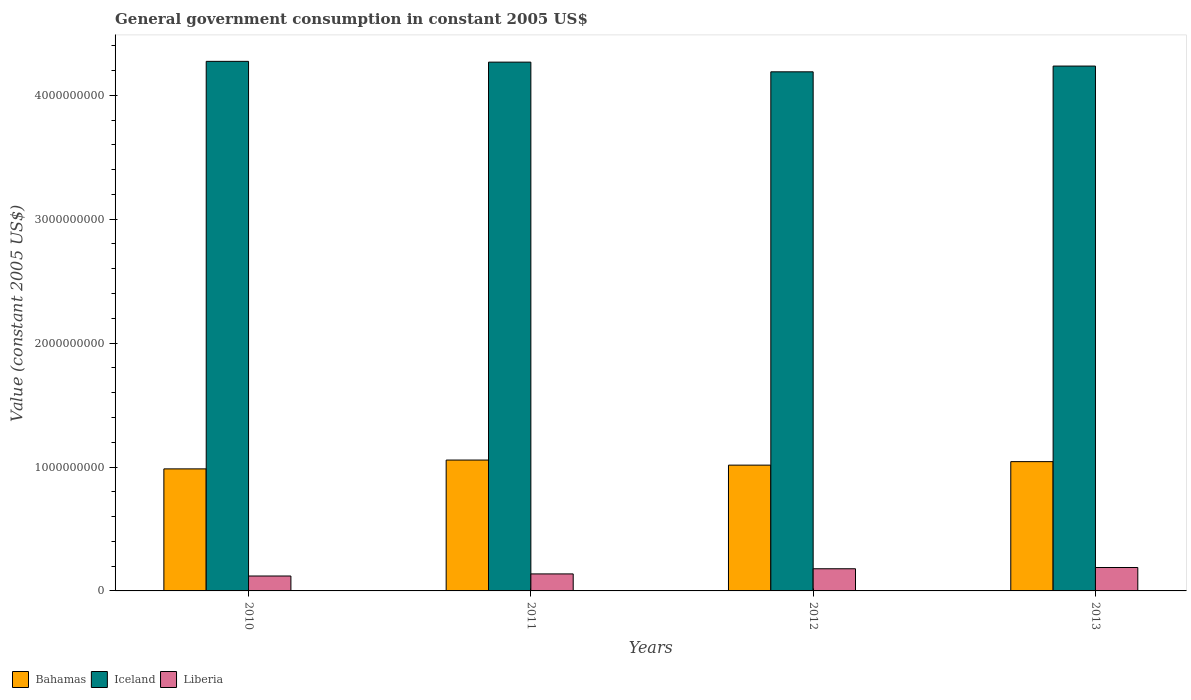Are the number of bars per tick equal to the number of legend labels?
Keep it short and to the point. Yes. How many bars are there on the 4th tick from the right?
Offer a very short reply. 3. In how many cases, is the number of bars for a given year not equal to the number of legend labels?
Your response must be concise. 0. What is the government conusmption in Bahamas in 2012?
Provide a succinct answer. 1.02e+09. Across all years, what is the maximum government conusmption in Iceland?
Your answer should be compact. 4.27e+09. Across all years, what is the minimum government conusmption in Liberia?
Offer a terse response. 1.20e+08. In which year was the government conusmption in Bahamas maximum?
Give a very brief answer. 2011. What is the total government conusmption in Bahamas in the graph?
Keep it short and to the point. 4.10e+09. What is the difference between the government conusmption in Liberia in 2011 and that in 2012?
Offer a very short reply. -4.16e+07. What is the difference between the government conusmption in Iceland in 2010 and the government conusmption in Liberia in 2012?
Provide a short and direct response. 4.10e+09. What is the average government conusmption in Liberia per year?
Give a very brief answer. 1.56e+08. In the year 2013, what is the difference between the government conusmption in Bahamas and government conusmption in Liberia?
Offer a terse response. 8.55e+08. In how many years, is the government conusmption in Liberia greater than 2800000000 US$?
Ensure brevity in your answer.  0. What is the ratio of the government conusmption in Bahamas in 2012 to that in 2013?
Ensure brevity in your answer.  0.97. Is the government conusmption in Liberia in 2011 less than that in 2012?
Ensure brevity in your answer.  Yes. What is the difference between the highest and the second highest government conusmption in Bahamas?
Your answer should be very brief. 1.28e+07. What is the difference between the highest and the lowest government conusmption in Bahamas?
Make the answer very short. 7.13e+07. Is the sum of the government conusmption in Bahamas in 2010 and 2013 greater than the maximum government conusmption in Liberia across all years?
Provide a succinct answer. Yes. What does the 3rd bar from the left in 2011 represents?
Your answer should be very brief. Liberia. What does the 3rd bar from the right in 2010 represents?
Your answer should be very brief. Bahamas. How many bars are there?
Provide a short and direct response. 12. Are all the bars in the graph horizontal?
Ensure brevity in your answer.  No. How many years are there in the graph?
Offer a terse response. 4. Does the graph contain any zero values?
Your answer should be very brief. No. How are the legend labels stacked?
Offer a terse response. Horizontal. What is the title of the graph?
Provide a succinct answer. General government consumption in constant 2005 US$. Does "Malaysia" appear as one of the legend labels in the graph?
Provide a short and direct response. No. What is the label or title of the X-axis?
Provide a short and direct response. Years. What is the label or title of the Y-axis?
Make the answer very short. Value (constant 2005 US$). What is the Value (constant 2005 US$) of Bahamas in 2010?
Provide a short and direct response. 9.85e+08. What is the Value (constant 2005 US$) of Iceland in 2010?
Give a very brief answer. 4.27e+09. What is the Value (constant 2005 US$) of Liberia in 2010?
Keep it short and to the point. 1.20e+08. What is the Value (constant 2005 US$) in Bahamas in 2011?
Your answer should be very brief. 1.06e+09. What is the Value (constant 2005 US$) in Iceland in 2011?
Provide a short and direct response. 4.27e+09. What is the Value (constant 2005 US$) in Liberia in 2011?
Provide a succinct answer. 1.37e+08. What is the Value (constant 2005 US$) in Bahamas in 2012?
Provide a short and direct response. 1.02e+09. What is the Value (constant 2005 US$) of Iceland in 2012?
Make the answer very short. 4.19e+09. What is the Value (constant 2005 US$) of Liberia in 2012?
Provide a short and direct response. 1.79e+08. What is the Value (constant 2005 US$) of Bahamas in 2013?
Offer a very short reply. 1.04e+09. What is the Value (constant 2005 US$) of Iceland in 2013?
Keep it short and to the point. 4.24e+09. What is the Value (constant 2005 US$) of Liberia in 2013?
Your answer should be compact. 1.89e+08. Across all years, what is the maximum Value (constant 2005 US$) of Bahamas?
Offer a very short reply. 1.06e+09. Across all years, what is the maximum Value (constant 2005 US$) of Iceland?
Offer a terse response. 4.27e+09. Across all years, what is the maximum Value (constant 2005 US$) of Liberia?
Your response must be concise. 1.89e+08. Across all years, what is the minimum Value (constant 2005 US$) of Bahamas?
Provide a short and direct response. 9.85e+08. Across all years, what is the minimum Value (constant 2005 US$) of Iceland?
Your answer should be very brief. 4.19e+09. Across all years, what is the minimum Value (constant 2005 US$) in Liberia?
Ensure brevity in your answer.  1.20e+08. What is the total Value (constant 2005 US$) of Bahamas in the graph?
Give a very brief answer. 4.10e+09. What is the total Value (constant 2005 US$) of Iceland in the graph?
Your response must be concise. 1.70e+1. What is the total Value (constant 2005 US$) of Liberia in the graph?
Make the answer very short. 6.26e+08. What is the difference between the Value (constant 2005 US$) of Bahamas in 2010 and that in 2011?
Your answer should be compact. -7.13e+07. What is the difference between the Value (constant 2005 US$) in Iceland in 2010 and that in 2011?
Make the answer very short. 6.32e+06. What is the difference between the Value (constant 2005 US$) of Liberia in 2010 and that in 2011?
Keep it short and to the point. -1.70e+07. What is the difference between the Value (constant 2005 US$) in Bahamas in 2010 and that in 2012?
Offer a very short reply. -3.03e+07. What is the difference between the Value (constant 2005 US$) in Iceland in 2010 and that in 2012?
Provide a succinct answer. 8.45e+07. What is the difference between the Value (constant 2005 US$) of Liberia in 2010 and that in 2012?
Ensure brevity in your answer.  -5.86e+07. What is the difference between the Value (constant 2005 US$) in Bahamas in 2010 and that in 2013?
Your answer should be compact. -5.85e+07. What is the difference between the Value (constant 2005 US$) in Iceland in 2010 and that in 2013?
Make the answer very short. 3.80e+07. What is the difference between the Value (constant 2005 US$) of Liberia in 2010 and that in 2013?
Make the answer very short. -6.86e+07. What is the difference between the Value (constant 2005 US$) of Bahamas in 2011 and that in 2012?
Give a very brief answer. 4.10e+07. What is the difference between the Value (constant 2005 US$) in Iceland in 2011 and that in 2012?
Provide a short and direct response. 7.82e+07. What is the difference between the Value (constant 2005 US$) of Liberia in 2011 and that in 2012?
Ensure brevity in your answer.  -4.16e+07. What is the difference between the Value (constant 2005 US$) of Bahamas in 2011 and that in 2013?
Your answer should be compact. 1.28e+07. What is the difference between the Value (constant 2005 US$) in Iceland in 2011 and that in 2013?
Offer a terse response. 3.17e+07. What is the difference between the Value (constant 2005 US$) in Liberia in 2011 and that in 2013?
Make the answer very short. -5.16e+07. What is the difference between the Value (constant 2005 US$) of Bahamas in 2012 and that in 2013?
Your answer should be compact. -2.82e+07. What is the difference between the Value (constant 2005 US$) of Iceland in 2012 and that in 2013?
Provide a succinct answer. -4.65e+07. What is the difference between the Value (constant 2005 US$) of Liberia in 2012 and that in 2013?
Give a very brief answer. -1.00e+07. What is the difference between the Value (constant 2005 US$) in Bahamas in 2010 and the Value (constant 2005 US$) in Iceland in 2011?
Keep it short and to the point. -3.28e+09. What is the difference between the Value (constant 2005 US$) of Bahamas in 2010 and the Value (constant 2005 US$) of Liberia in 2011?
Your answer should be compact. 8.48e+08. What is the difference between the Value (constant 2005 US$) in Iceland in 2010 and the Value (constant 2005 US$) in Liberia in 2011?
Ensure brevity in your answer.  4.14e+09. What is the difference between the Value (constant 2005 US$) of Bahamas in 2010 and the Value (constant 2005 US$) of Iceland in 2012?
Offer a very short reply. -3.20e+09. What is the difference between the Value (constant 2005 US$) of Bahamas in 2010 and the Value (constant 2005 US$) of Liberia in 2012?
Make the answer very short. 8.06e+08. What is the difference between the Value (constant 2005 US$) in Iceland in 2010 and the Value (constant 2005 US$) in Liberia in 2012?
Your response must be concise. 4.10e+09. What is the difference between the Value (constant 2005 US$) in Bahamas in 2010 and the Value (constant 2005 US$) in Iceland in 2013?
Offer a very short reply. -3.25e+09. What is the difference between the Value (constant 2005 US$) in Bahamas in 2010 and the Value (constant 2005 US$) in Liberia in 2013?
Offer a terse response. 7.96e+08. What is the difference between the Value (constant 2005 US$) of Iceland in 2010 and the Value (constant 2005 US$) of Liberia in 2013?
Ensure brevity in your answer.  4.09e+09. What is the difference between the Value (constant 2005 US$) of Bahamas in 2011 and the Value (constant 2005 US$) of Iceland in 2012?
Offer a terse response. -3.13e+09. What is the difference between the Value (constant 2005 US$) in Bahamas in 2011 and the Value (constant 2005 US$) in Liberia in 2012?
Your response must be concise. 8.77e+08. What is the difference between the Value (constant 2005 US$) of Iceland in 2011 and the Value (constant 2005 US$) of Liberia in 2012?
Offer a terse response. 4.09e+09. What is the difference between the Value (constant 2005 US$) of Bahamas in 2011 and the Value (constant 2005 US$) of Iceland in 2013?
Provide a succinct answer. -3.18e+09. What is the difference between the Value (constant 2005 US$) of Bahamas in 2011 and the Value (constant 2005 US$) of Liberia in 2013?
Keep it short and to the point. 8.67e+08. What is the difference between the Value (constant 2005 US$) of Iceland in 2011 and the Value (constant 2005 US$) of Liberia in 2013?
Ensure brevity in your answer.  4.08e+09. What is the difference between the Value (constant 2005 US$) of Bahamas in 2012 and the Value (constant 2005 US$) of Iceland in 2013?
Offer a very short reply. -3.22e+09. What is the difference between the Value (constant 2005 US$) of Bahamas in 2012 and the Value (constant 2005 US$) of Liberia in 2013?
Your answer should be compact. 8.26e+08. What is the difference between the Value (constant 2005 US$) of Iceland in 2012 and the Value (constant 2005 US$) of Liberia in 2013?
Ensure brevity in your answer.  4.00e+09. What is the average Value (constant 2005 US$) in Bahamas per year?
Make the answer very short. 1.02e+09. What is the average Value (constant 2005 US$) in Iceland per year?
Ensure brevity in your answer.  4.24e+09. What is the average Value (constant 2005 US$) of Liberia per year?
Provide a short and direct response. 1.56e+08. In the year 2010, what is the difference between the Value (constant 2005 US$) of Bahamas and Value (constant 2005 US$) of Iceland?
Provide a succinct answer. -3.29e+09. In the year 2010, what is the difference between the Value (constant 2005 US$) in Bahamas and Value (constant 2005 US$) in Liberia?
Your answer should be very brief. 8.65e+08. In the year 2010, what is the difference between the Value (constant 2005 US$) of Iceland and Value (constant 2005 US$) of Liberia?
Offer a terse response. 4.15e+09. In the year 2011, what is the difference between the Value (constant 2005 US$) of Bahamas and Value (constant 2005 US$) of Iceland?
Provide a succinct answer. -3.21e+09. In the year 2011, what is the difference between the Value (constant 2005 US$) of Bahamas and Value (constant 2005 US$) of Liberia?
Give a very brief answer. 9.19e+08. In the year 2011, what is the difference between the Value (constant 2005 US$) in Iceland and Value (constant 2005 US$) in Liberia?
Ensure brevity in your answer.  4.13e+09. In the year 2012, what is the difference between the Value (constant 2005 US$) of Bahamas and Value (constant 2005 US$) of Iceland?
Provide a short and direct response. -3.17e+09. In the year 2012, what is the difference between the Value (constant 2005 US$) of Bahamas and Value (constant 2005 US$) of Liberia?
Make the answer very short. 8.36e+08. In the year 2012, what is the difference between the Value (constant 2005 US$) of Iceland and Value (constant 2005 US$) of Liberia?
Give a very brief answer. 4.01e+09. In the year 2013, what is the difference between the Value (constant 2005 US$) of Bahamas and Value (constant 2005 US$) of Iceland?
Provide a succinct answer. -3.19e+09. In the year 2013, what is the difference between the Value (constant 2005 US$) of Bahamas and Value (constant 2005 US$) of Liberia?
Your answer should be compact. 8.55e+08. In the year 2013, what is the difference between the Value (constant 2005 US$) in Iceland and Value (constant 2005 US$) in Liberia?
Your answer should be very brief. 4.05e+09. What is the ratio of the Value (constant 2005 US$) in Bahamas in 2010 to that in 2011?
Offer a very short reply. 0.93. What is the ratio of the Value (constant 2005 US$) in Iceland in 2010 to that in 2011?
Give a very brief answer. 1. What is the ratio of the Value (constant 2005 US$) in Liberia in 2010 to that in 2011?
Provide a short and direct response. 0.88. What is the ratio of the Value (constant 2005 US$) of Bahamas in 2010 to that in 2012?
Offer a terse response. 0.97. What is the ratio of the Value (constant 2005 US$) of Iceland in 2010 to that in 2012?
Your answer should be compact. 1.02. What is the ratio of the Value (constant 2005 US$) in Liberia in 2010 to that in 2012?
Offer a very short reply. 0.67. What is the ratio of the Value (constant 2005 US$) in Bahamas in 2010 to that in 2013?
Provide a short and direct response. 0.94. What is the ratio of the Value (constant 2005 US$) of Liberia in 2010 to that in 2013?
Provide a succinct answer. 0.64. What is the ratio of the Value (constant 2005 US$) in Bahamas in 2011 to that in 2012?
Keep it short and to the point. 1.04. What is the ratio of the Value (constant 2005 US$) of Iceland in 2011 to that in 2012?
Provide a short and direct response. 1.02. What is the ratio of the Value (constant 2005 US$) of Liberia in 2011 to that in 2012?
Your answer should be very brief. 0.77. What is the ratio of the Value (constant 2005 US$) in Bahamas in 2011 to that in 2013?
Ensure brevity in your answer.  1.01. What is the ratio of the Value (constant 2005 US$) in Iceland in 2011 to that in 2013?
Provide a short and direct response. 1.01. What is the ratio of the Value (constant 2005 US$) of Liberia in 2011 to that in 2013?
Provide a short and direct response. 0.73. What is the ratio of the Value (constant 2005 US$) of Bahamas in 2012 to that in 2013?
Your answer should be compact. 0.97. What is the ratio of the Value (constant 2005 US$) in Liberia in 2012 to that in 2013?
Your answer should be very brief. 0.95. What is the difference between the highest and the second highest Value (constant 2005 US$) in Bahamas?
Your answer should be compact. 1.28e+07. What is the difference between the highest and the second highest Value (constant 2005 US$) of Iceland?
Provide a succinct answer. 6.32e+06. What is the difference between the highest and the second highest Value (constant 2005 US$) in Liberia?
Offer a very short reply. 1.00e+07. What is the difference between the highest and the lowest Value (constant 2005 US$) of Bahamas?
Your response must be concise. 7.13e+07. What is the difference between the highest and the lowest Value (constant 2005 US$) in Iceland?
Ensure brevity in your answer.  8.45e+07. What is the difference between the highest and the lowest Value (constant 2005 US$) of Liberia?
Offer a very short reply. 6.86e+07. 